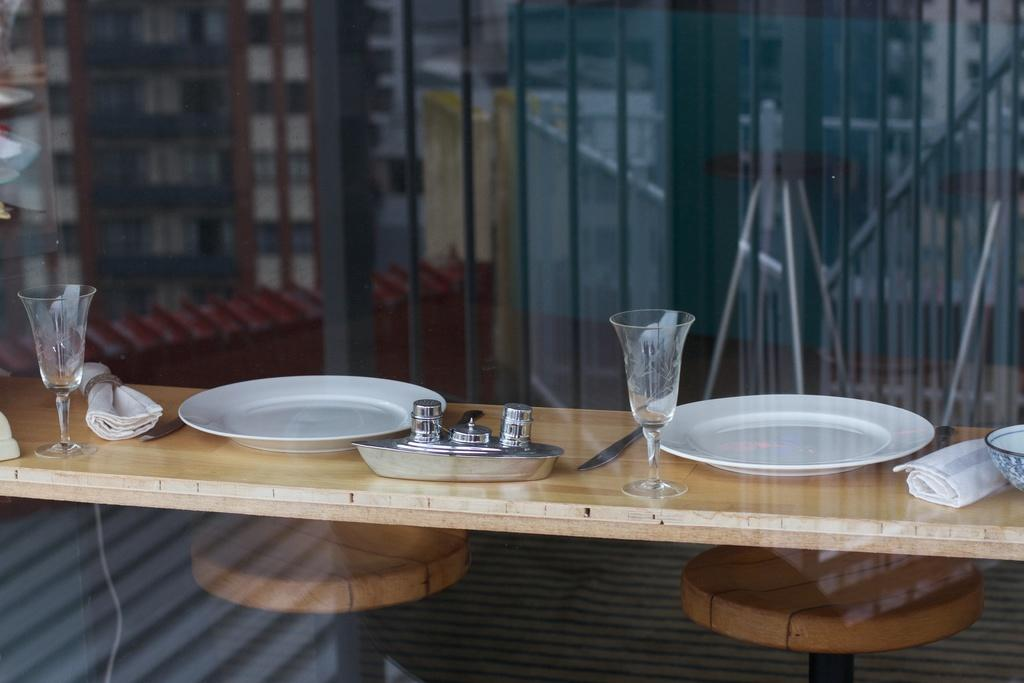What objects are on the table in the image? There are plates and glasses on the table in the image. Can you describe the table setting in more detail? The table setting includes plates and glasses, which suggests it might be a dining area. What type of sack is hanging on the wall in the image? There is no sack present in the image, nor is there a wall visible. 